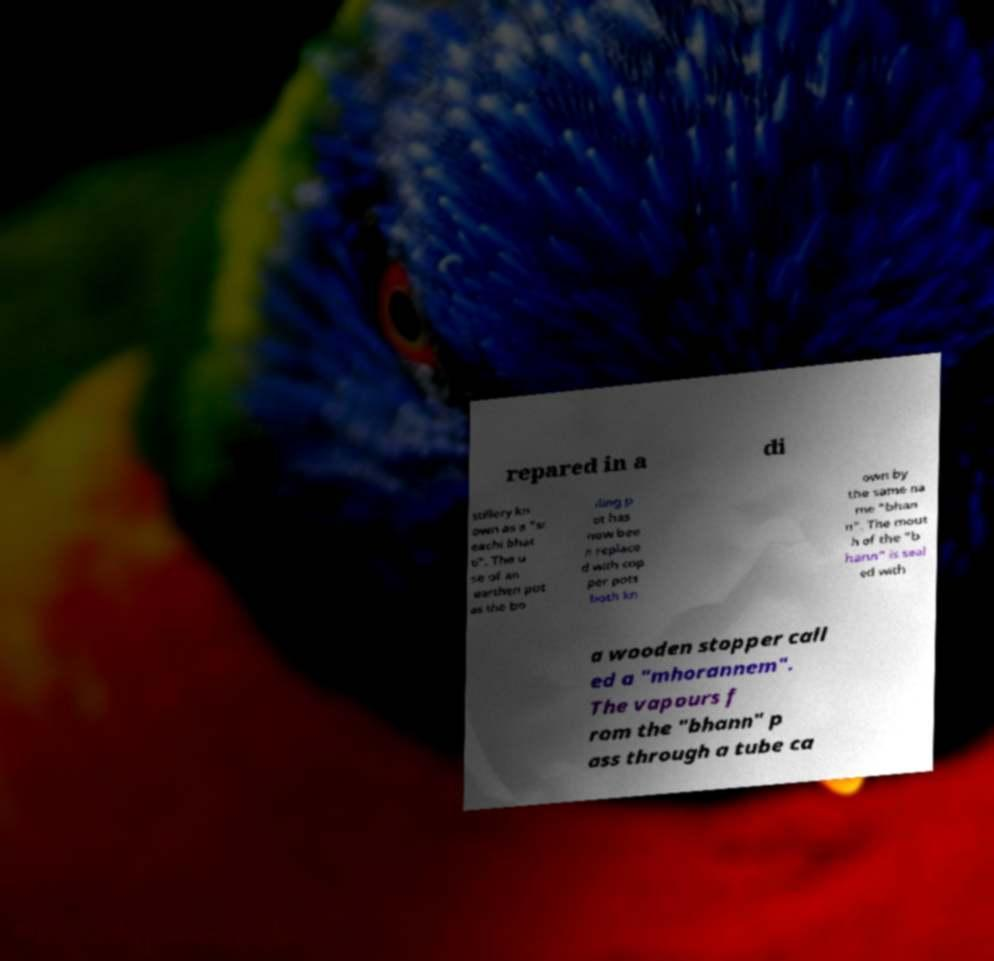Can you accurately transcribe the text from the provided image for me? repared in a di stillery kn own as a "sr eachi bhat ti". The u se of an earthen pot as the bo iling p ot has now bee n replace d with cop per pots both kn own by the same na me "bhan n". The mout h of the "b hann" is seal ed with a wooden stopper call ed a "mhorannem". The vapours f rom the "bhann" p ass through a tube ca 